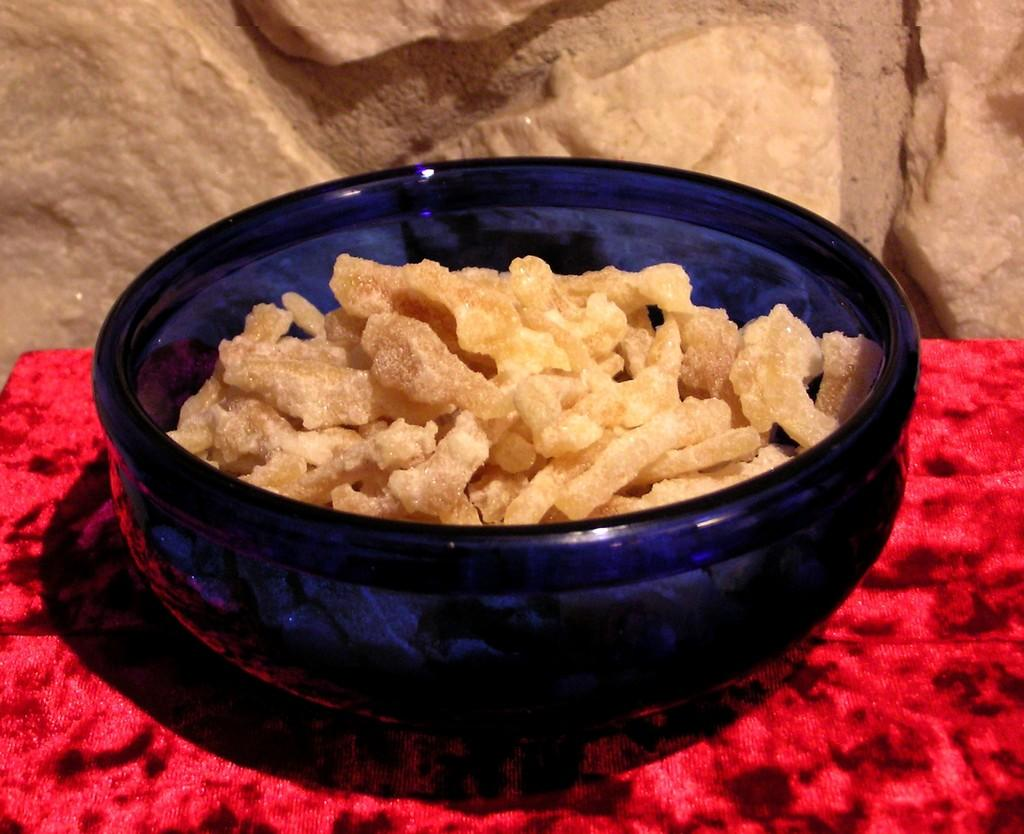What is on the table in the image? There is a bowl on the table in the image. What is inside the bowl? There is a food item in the bowl. What type of structure can be seen in the image? There is a stone wall in the image. Can you see a swing hanging from the stone wall in the image? There is no swing present in the image; it only features a bowl on a table and a stone wall. Is there any butter visible in the image? There is no butter mentioned or visible in the image; it only contains a bowl with a food item and a stone wall. 